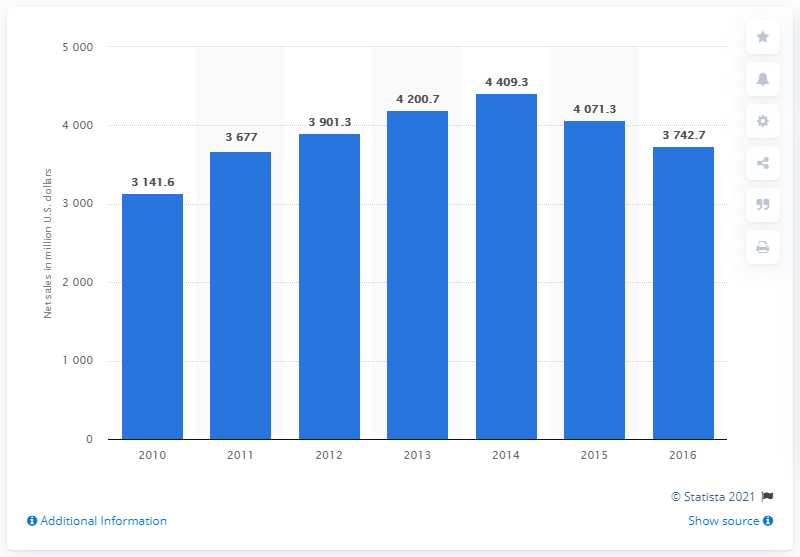Outline some significant characteristics in this image. In 2013, the global net sales of Mead Johnson Nutrition Company were approximately 4,200.7. 